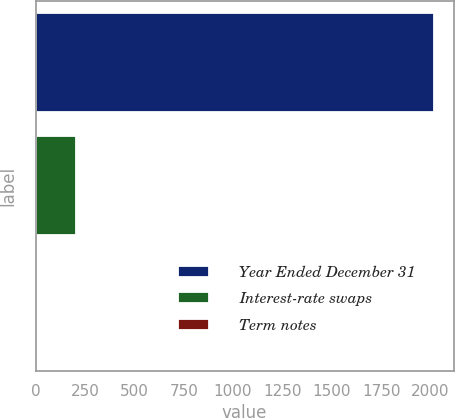<chart> <loc_0><loc_0><loc_500><loc_500><bar_chart><fcel>Year Ended December 31<fcel>Interest-rate swaps<fcel>Term notes<nl><fcel>2017<fcel>203.05<fcel>1.5<nl></chart> 